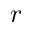<formula> <loc_0><loc_0><loc_500><loc_500>r</formula> 